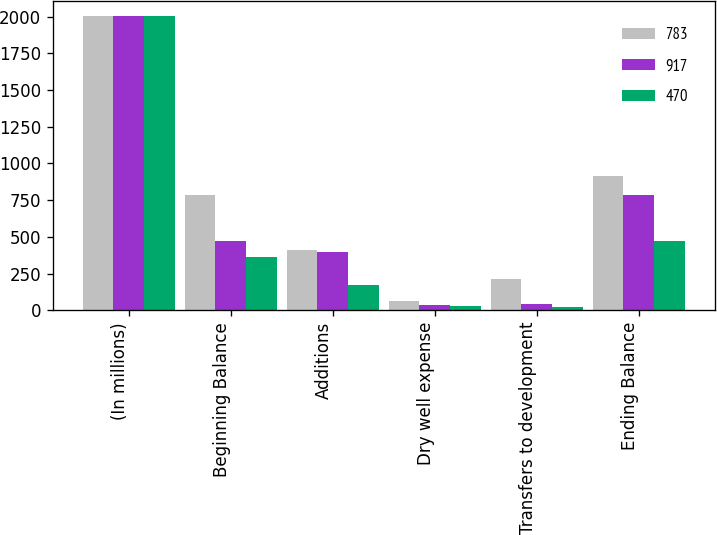Convert chart to OTSL. <chart><loc_0><loc_0><loc_500><loc_500><stacked_bar_chart><ecel><fcel>(In millions)<fcel>Beginning Balance<fcel>Additions<fcel>Dry well expense<fcel>Transfers to development<fcel>Ending Balance<nl><fcel>783<fcel>2008<fcel>783<fcel>413<fcel>63<fcel>216<fcel>917<nl><fcel>917<fcel>2007<fcel>470<fcel>394<fcel>39<fcel>42<fcel>783<nl><fcel>470<fcel>2006<fcel>363<fcel>174<fcel>27<fcel>21<fcel>470<nl></chart> 